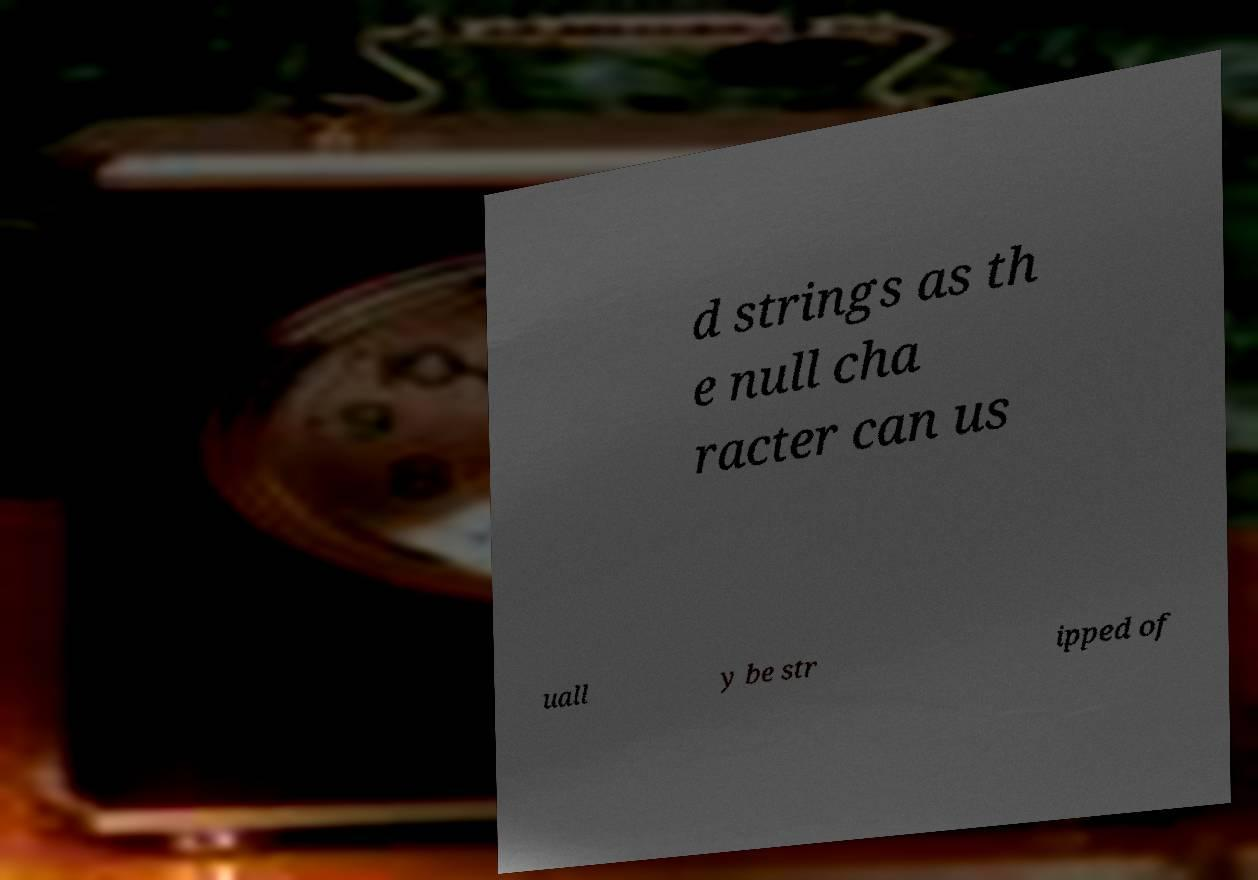Could you extract and type out the text from this image? d strings as th e null cha racter can us uall y be str ipped of 